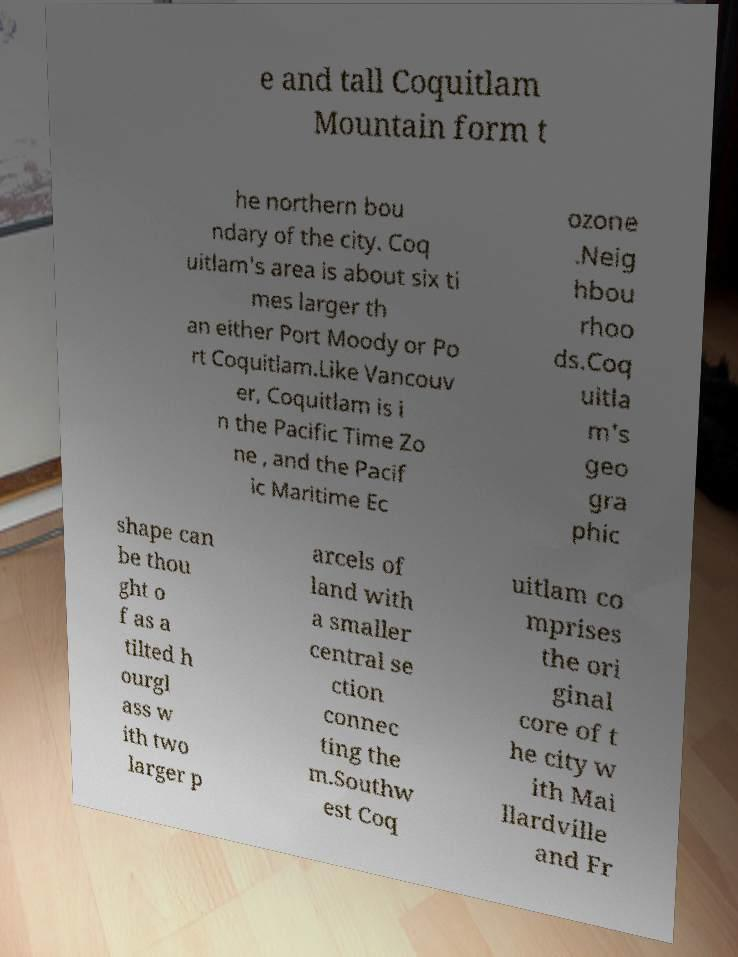Please read and relay the text visible in this image. What does it say? e and tall Coquitlam Mountain form t he northern bou ndary of the city. Coq uitlam's area is about six ti mes larger th an either Port Moody or Po rt Coquitlam.Like Vancouv er, Coquitlam is i n the Pacific Time Zo ne , and the Pacif ic Maritime Ec ozone .Neig hbou rhoo ds.Coq uitla m's geo gra phic shape can be thou ght o f as a tilted h ourgl ass w ith two larger p arcels of land with a smaller central se ction connec ting the m.Southw est Coq uitlam co mprises the ori ginal core of t he city w ith Mai llardville and Fr 